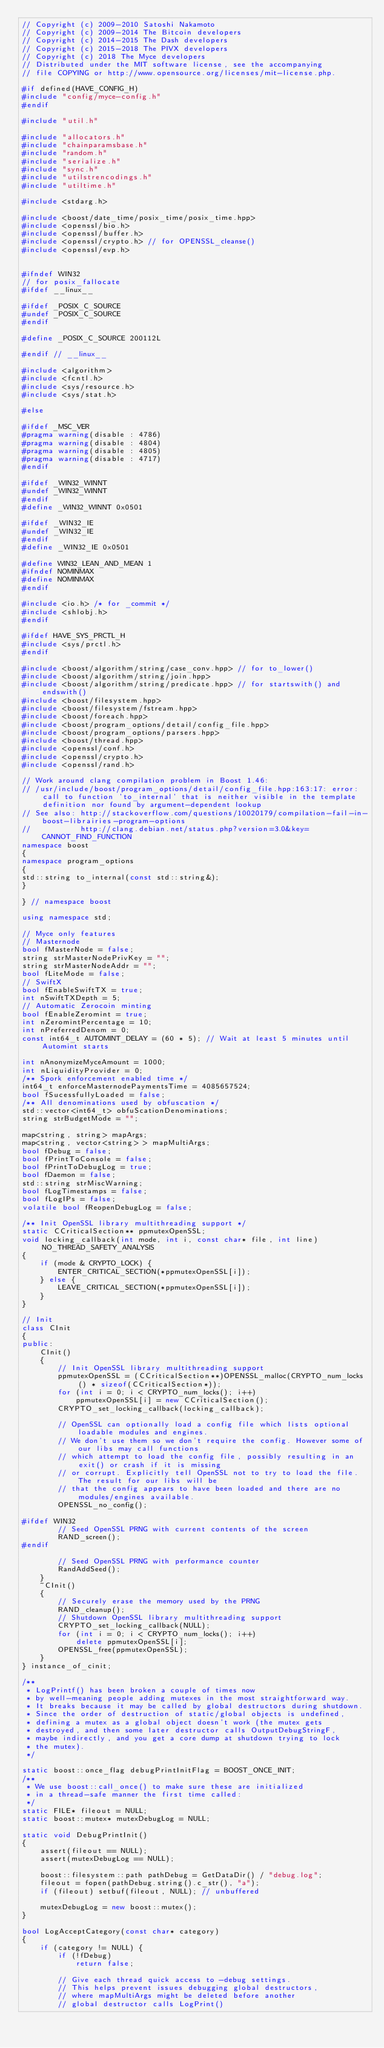<code> <loc_0><loc_0><loc_500><loc_500><_C++_>// Copyright (c) 2009-2010 Satoshi Nakamoto
// Copyright (c) 2009-2014 The Bitcoin developers
// Copyright (c) 2014-2015 The Dash developers
// Copyright (c) 2015-2018 The PIVX developers
// Copyright (c) 2018 The Myce developers
// Distributed under the MIT software license, see the accompanying
// file COPYING or http://www.opensource.org/licenses/mit-license.php.

#if defined(HAVE_CONFIG_H)
#include "config/myce-config.h"
#endif

#include "util.h"

#include "allocators.h"
#include "chainparamsbase.h"
#include "random.h"
#include "serialize.h"
#include "sync.h"
#include "utilstrencodings.h"
#include "utiltime.h"

#include <stdarg.h>

#include <boost/date_time/posix_time/posix_time.hpp>
#include <openssl/bio.h>
#include <openssl/buffer.h>
#include <openssl/crypto.h> // for OPENSSL_cleanse()
#include <openssl/evp.h>


#ifndef WIN32
// for posix_fallocate
#ifdef __linux__

#ifdef _POSIX_C_SOURCE
#undef _POSIX_C_SOURCE
#endif

#define _POSIX_C_SOURCE 200112L

#endif // __linux__

#include <algorithm>
#include <fcntl.h>
#include <sys/resource.h>
#include <sys/stat.h>

#else

#ifdef _MSC_VER
#pragma warning(disable : 4786)
#pragma warning(disable : 4804)
#pragma warning(disable : 4805)
#pragma warning(disable : 4717)
#endif

#ifdef _WIN32_WINNT
#undef _WIN32_WINNT
#endif
#define _WIN32_WINNT 0x0501

#ifdef _WIN32_IE
#undef _WIN32_IE
#endif
#define _WIN32_IE 0x0501

#define WIN32_LEAN_AND_MEAN 1
#ifndef NOMINMAX
#define NOMINMAX
#endif

#include <io.h> /* for _commit */
#include <shlobj.h>
#endif

#ifdef HAVE_SYS_PRCTL_H
#include <sys/prctl.h>
#endif

#include <boost/algorithm/string/case_conv.hpp> // for to_lower()
#include <boost/algorithm/string/join.hpp>
#include <boost/algorithm/string/predicate.hpp> // for startswith() and endswith()
#include <boost/filesystem.hpp>
#include <boost/filesystem/fstream.hpp>
#include <boost/foreach.hpp>
#include <boost/program_options/detail/config_file.hpp>
#include <boost/program_options/parsers.hpp>
#include <boost/thread.hpp>
#include <openssl/conf.h>
#include <openssl/crypto.h>
#include <openssl/rand.h>

// Work around clang compilation problem in Boost 1.46:
// /usr/include/boost/program_options/detail/config_file.hpp:163:17: error: call to function 'to_internal' that is neither visible in the template definition nor found by argument-dependent lookup
// See also: http://stackoverflow.com/questions/10020179/compilation-fail-in-boost-librairies-program-options
//           http://clang.debian.net/status.php?version=3.0&key=CANNOT_FIND_FUNCTION
namespace boost
{
namespace program_options
{
std::string to_internal(const std::string&);
}

} // namespace boost

using namespace std;

// Myce only features
// Masternode
bool fMasterNode = false;
string strMasterNodePrivKey = "";
string strMasterNodeAddr = "";
bool fLiteMode = false;
// SwiftX
bool fEnableSwiftTX = true;
int nSwiftTXDepth = 5;
// Automatic Zerocoin minting
bool fEnableZeromint = true;
int nZeromintPercentage = 10;
int nPreferredDenom = 0;
const int64_t AUTOMINT_DELAY = (60 * 5); // Wait at least 5 minutes until Automint starts

int nAnonymizeMyceAmount = 1000;
int nLiquidityProvider = 0;
/** Spork enforcement enabled time */
int64_t enforceMasternodePaymentsTime = 4085657524;
bool fSucessfullyLoaded = false;
/** All denominations used by obfuscation */
std::vector<int64_t> obfuScationDenominations;
string strBudgetMode = "";

map<string, string> mapArgs;
map<string, vector<string> > mapMultiArgs;
bool fDebug = false;
bool fPrintToConsole = false;
bool fPrintToDebugLog = true;
bool fDaemon = false;
std::string strMiscWarning;
bool fLogTimestamps = false;
bool fLogIPs = false;
volatile bool fReopenDebugLog = false;

/** Init OpenSSL library multithreading support */
static CCriticalSection** ppmutexOpenSSL;
void locking_callback(int mode, int i, const char* file, int line) NO_THREAD_SAFETY_ANALYSIS
{
    if (mode & CRYPTO_LOCK) {
        ENTER_CRITICAL_SECTION(*ppmutexOpenSSL[i]);
    } else {
        LEAVE_CRITICAL_SECTION(*ppmutexOpenSSL[i]);
    }
}

// Init
class CInit
{
public:
    CInit()
    {
        // Init OpenSSL library multithreading support
        ppmutexOpenSSL = (CCriticalSection**)OPENSSL_malloc(CRYPTO_num_locks() * sizeof(CCriticalSection*));
        for (int i = 0; i < CRYPTO_num_locks(); i++)
            ppmutexOpenSSL[i] = new CCriticalSection();
        CRYPTO_set_locking_callback(locking_callback);

        // OpenSSL can optionally load a config file which lists optional loadable modules and engines.
        // We don't use them so we don't require the config. However some of our libs may call functions
        // which attempt to load the config file, possibly resulting in an exit() or crash if it is missing
        // or corrupt. Explicitly tell OpenSSL not to try to load the file. The result for our libs will be
        // that the config appears to have been loaded and there are no modules/engines available.
        OPENSSL_no_config();

#ifdef WIN32
        // Seed OpenSSL PRNG with current contents of the screen
        RAND_screen();
#endif

        // Seed OpenSSL PRNG with performance counter
        RandAddSeed();
    }
    ~CInit()
    {
        // Securely erase the memory used by the PRNG
        RAND_cleanup();
        // Shutdown OpenSSL library multithreading support
        CRYPTO_set_locking_callback(NULL);
        for (int i = 0; i < CRYPTO_num_locks(); i++)
            delete ppmutexOpenSSL[i];
        OPENSSL_free(ppmutexOpenSSL);
    }
} instance_of_cinit;

/**
 * LogPrintf() has been broken a couple of times now
 * by well-meaning people adding mutexes in the most straightforward way.
 * It breaks because it may be called by global destructors during shutdown.
 * Since the order of destruction of static/global objects is undefined,
 * defining a mutex as a global object doesn't work (the mutex gets
 * destroyed, and then some later destructor calls OutputDebugStringF,
 * maybe indirectly, and you get a core dump at shutdown trying to lock
 * the mutex).
 */

static boost::once_flag debugPrintInitFlag = BOOST_ONCE_INIT;
/**
 * We use boost::call_once() to make sure these are initialized
 * in a thread-safe manner the first time called:
 */
static FILE* fileout = NULL;
static boost::mutex* mutexDebugLog = NULL;

static void DebugPrintInit()
{
    assert(fileout == NULL);
    assert(mutexDebugLog == NULL);

    boost::filesystem::path pathDebug = GetDataDir() / "debug.log";
    fileout = fopen(pathDebug.string().c_str(), "a");
    if (fileout) setbuf(fileout, NULL); // unbuffered

    mutexDebugLog = new boost::mutex();
}

bool LogAcceptCategory(const char* category)
{
    if (category != NULL) {
        if (!fDebug)
            return false;

        // Give each thread quick access to -debug settings.
        // This helps prevent issues debugging global destructors,
        // where mapMultiArgs might be deleted before another
        // global destructor calls LogPrint()</code> 